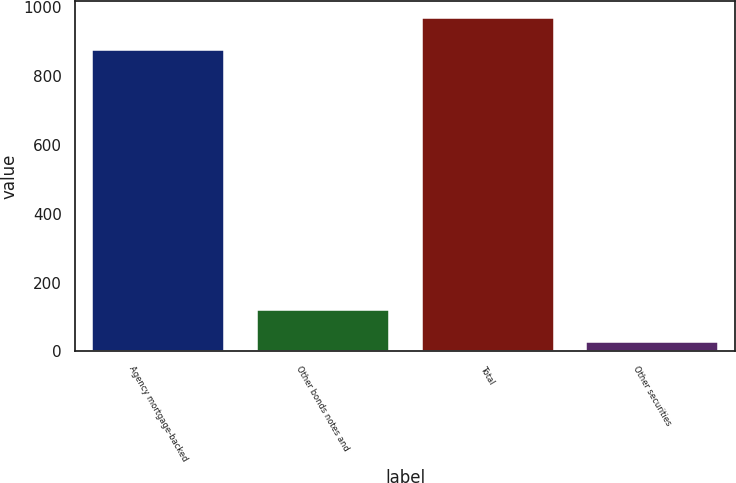<chart> <loc_0><loc_0><loc_500><loc_500><bar_chart><fcel>Agency mortgage-backed<fcel>Other bonds notes and<fcel>Total<fcel>Other securities<nl><fcel>876<fcel>120.6<fcel>969.6<fcel>27<nl></chart> 